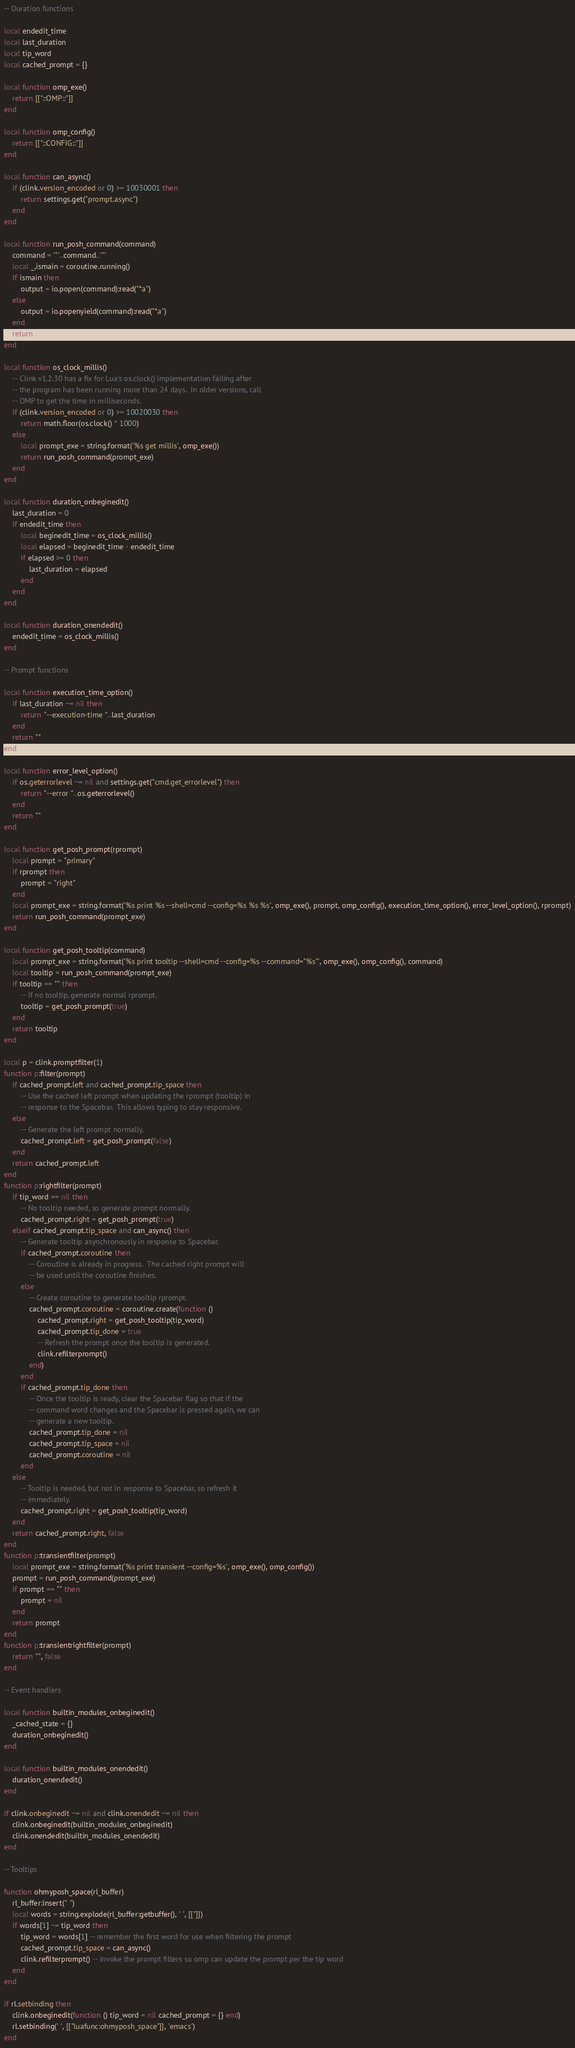Convert code to text. <code><loc_0><loc_0><loc_500><loc_500><_Lua_>-- Duration functions

local endedit_time
local last_duration
local tip_word
local cached_prompt = {}

local function omp_exe()
    return [["::OMP::"]]
end

local function omp_config()
    return [["::CONFIG::"]]
end

local function can_async()
    if (clink.version_encoded or 0) >= 10030001 then
        return settings.get("prompt.async")
    end
end

local function run_posh_command(command)
    command = '"'..command..'"'
    local _,ismain = coroutine.running()
    if ismain then
        output = io.popen(command):read("*a")
    else
        output = io.popenyield(command):read("*a")
    end
    return output
end

local function os_clock_millis()
    -- Clink v1.2.30 has a fix for Lua's os.clock() implementation failing after
    -- the program has been running more than 24 days.  In older versions, call
    -- OMP to get the time in milliseconds.
    if (clink.version_encoded or 0) >= 10020030 then
        return math.floor(os.clock() * 1000)
    else
        local prompt_exe = string.format('%s get millis', omp_exe())
        return run_posh_command(prompt_exe)
    end
end

local function duration_onbeginedit()
    last_duration = 0
    if endedit_time then
        local beginedit_time = os_clock_millis()
        local elapsed = beginedit_time - endedit_time
        if elapsed >= 0 then
            last_duration = elapsed
        end
    end
end

local function duration_onendedit()
    endedit_time = os_clock_millis()
end

-- Prompt functions

local function execution_time_option()
    if last_duration ~= nil then
        return "--execution-time "..last_duration
    end
    return ""
end

local function error_level_option()
    if os.geterrorlevel ~= nil and settings.get("cmd.get_errorlevel") then
        return "--error "..os.geterrorlevel()
    end
    return ""
end

local function get_posh_prompt(rprompt)
    local prompt = "primary"
    if rprompt then
        prompt = "right"
    end
    local prompt_exe = string.format('%s print %s --shell=cmd --config=%s %s %s', omp_exe(), prompt, omp_config(), execution_time_option(), error_level_option(), rprompt)
    return run_posh_command(prompt_exe)
end

local function get_posh_tooltip(command)
    local prompt_exe = string.format('%s print tooltip --shell=cmd --config=%s --command="%s"', omp_exe(), omp_config(), command)
    local tooltip = run_posh_command(prompt_exe)
    if tooltip == "" then
        -- If no tooltip, generate normal rprompt.
        tooltip = get_posh_prompt(true)
    end
    return tooltip
end

local p = clink.promptfilter(1)
function p:filter(prompt)
    if cached_prompt.left and cached_prompt.tip_space then
        -- Use the cached left prompt when updating the rprompt (tooltip) in
        -- response to the Spacebar.  This allows typing to stay responsive.
    else
        -- Generate the left prompt normally.
        cached_prompt.left = get_posh_prompt(false)
    end
    return cached_prompt.left
end
function p:rightfilter(prompt)
    if tip_word == nil then
        -- No tooltip needed, so generate prompt normally.
        cached_prompt.right = get_posh_prompt(true)
    elseif cached_prompt.tip_space and can_async() then
        -- Generate tooltip asynchronously in response to Spacebar.
        if cached_prompt.coroutine then
            -- Coroutine is already in progress.  The cached right prompt will
            -- be used until the coroutine finishes.
        else
            -- Create coroutine to generate tooltip rprompt.
            cached_prompt.coroutine = coroutine.create(function ()
                cached_prompt.right = get_posh_tooltip(tip_word)
                cached_prompt.tip_done = true
                -- Refresh the prompt once the tooltip is generated.
                clink.refilterprompt()
            end)
        end
        if cached_prompt.tip_done then
            -- Once the tooltip is ready, clear the Spacebar flag so that if the
            -- command word changes and the Spacebar is pressed again, we can
            -- generate a new tooltip.
            cached_prompt.tip_done = nil
            cached_prompt.tip_space = nil
            cached_prompt.coroutine = nil
        end
    else
        -- Tooltip is needed, but not in response to Spacebar, so refresh it
        -- immediately.
        cached_prompt.right = get_posh_tooltip(tip_word)
    end
    return cached_prompt.right, false
end
function p:transientfilter(prompt)
    local prompt_exe = string.format('%s print transient --config=%s', omp_exe(), omp_config())
    prompt = run_posh_command(prompt_exe)
    if prompt == "" then
        prompt = nil
    end
    return prompt
end
function p:transientrightfilter(prompt)
    return "", false
end

-- Event handlers

local function builtin_modules_onbeginedit()
    _cached_state = {}
    duration_onbeginedit()
end

local function builtin_modules_onendedit()
    duration_onendedit()
end

if clink.onbeginedit ~= nil and clink.onendedit ~= nil then
    clink.onbeginedit(builtin_modules_onbeginedit)
    clink.onendedit(builtin_modules_onendedit)
end

-- Tooltips

function ohmyposh_space(rl_buffer)
    rl_buffer:insert(" ")
    local words = string.explode(rl_buffer:getbuffer(), ' ', [["]])
    if words[1] ~= tip_word then
        tip_word = words[1] -- remember the first word for use when filtering the prompt
        cached_prompt.tip_space = can_async()
        clink.refilterprompt() -- invoke the prompt filters so omp can update the prompt per the tip word
    end
end

if rl.setbinding then
    clink.onbeginedit(function () tip_word = nil cached_prompt = {} end)
    rl.setbinding(' ', [["luafunc:ohmyposh_space"]], 'emacs')
end
</code> 